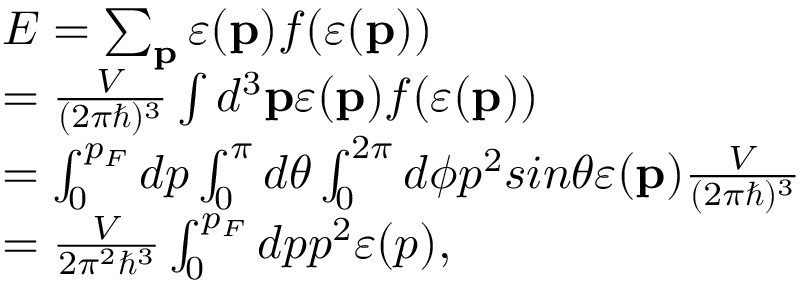Convert formula to latex. <formula><loc_0><loc_0><loc_500><loc_500>\begin{array} { l } { E = \sum _ { p } \varepsilon ( p ) f ( \varepsilon ( p ) ) } \\ { = \frac { V } { ( 2 \pi \hbar { ) } ^ { 3 } } \int d ^ { 3 } p \varepsilon ( p ) f ( \varepsilon ( p ) ) } \\ { = \int _ { 0 } ^ { p _ { F } } d p \int _ { 0 } ^ { \pi } d \theta \int _ { 0 } ^ { 2 \pi } d \phi p ^ { 2 } \sin \theta \varepsilon ( p ) \frac { V } { ( 2 \pi \hbar { ) } ^ { 3 } } } \\ { = \frac { V } { 2 \pi ^ { 2 } \hbar { ^ } { 3 } } \int _ { 0 } ^ { p _ { F } } d p p ^ { 2 } \varepsilon ( p ) , } \end{array}</formula> 